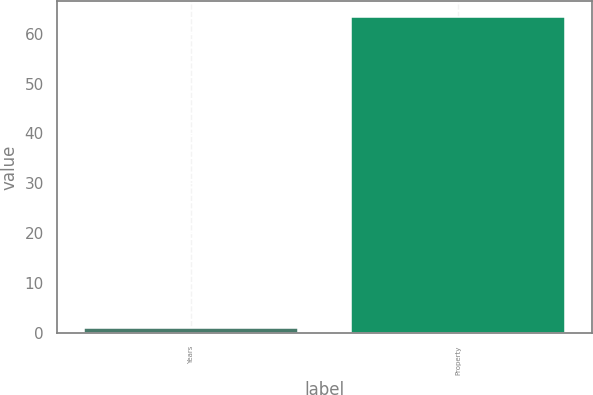<chart> <loc_0><loc_0><loc_500><loc_500><bar_chart><fcel>Years<fcel>Property<nl><fcel>1<fcel>63.4<nl></chart> 